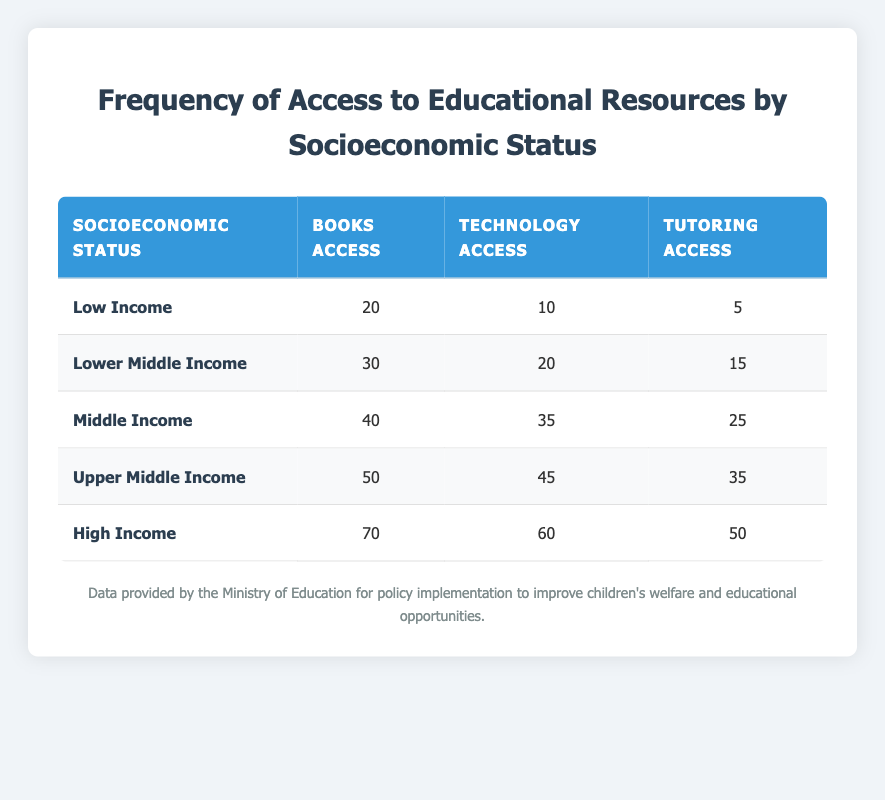What is the frequency of access to books for families in the Upper Middle Income category? According to the table, the frequency of access to books for families in the Upper Middle Income category is explicitly stated in the "Books Access" column for that row. The value for Upper Middle Income is 50.
Answer: 50 How many more families in High Income have access to technology compared to Low Income families? To find the difference, subtract the frequency of access to technology for Low Income (10) from the frequency for High Income (60): 60 - 10 = 50.
Answer: 50 What is the total frequency of access to tutoring across all income levels? The total frequency of access to tutoring can be calculated by adding all values in the "Tutoring Access" column: 5 (Low Income) + 15 (Lower Middle Income) + 25 (Middle Income) + 35 (Upper Middle Income) + 50 (High Income) = 130.
Answer: 130 Is it true that families in Middle Income have more access to technology than families in Lower Middle Income? By comparing the "Technology Access" values in the respective rows, Middle Income has 35 while Lower Middle Income has 20. Since 35 is greater than 20, the statement is true.
Answer: Yes What is the average frequency of access to books for all socioeconomic statuses? To find the average, add all the values from the "Books Access" column: 20 + 30 + 40 + 50 + 70 = 210. Then divide by the number of income categories, which is 5: 210 / 5 = 42.
Answer: 42 How many families in Upper Middle Income have access to both technology and tutoring? The "Technology Access" for Upper Middle Income is 45, and the "Tutoring Access" is 35. Hence, the values indicate access, so both numbers represent individual counts for different resources. The question implies to verify if they have access, which they do.
Answer: Yes How does the frequency of access to tutoring for Lower Middle Income compare to High Income? The "Tutoring Access" for Lower Middle Income is 15, while for High Income it is 50. Since 15 is less than 50, Lower Middle Income families have less access to tutoring compared to High Income families.
Answer: Lower What is the difference in frequency of access to books between Low Income and High Income? To find the difference, subtract the frequency for Low Income (20) from High Income (70): 70 - 20 = 50.
Answer: 50 